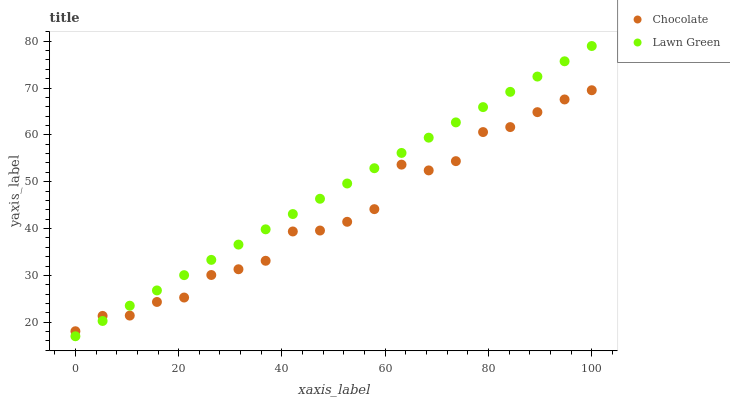Does Chocolate have the minimum area under the curve?
Answer yes or no. Yes. Does Lawn Green have the maximum area under the curve?
Answer yes or no. Yes. Does Chocolate have the maximum area under the curve?
Answer yes or no. No. Is Lawn Green the smoothest?
Answer yes or no. Yes. Is Chocolate the roughest?
Answer yes or no. Yes. Is Chocolate the smoothest?
Answer yes or no. No. Does Lawn Green have the lowest value?
Answer yes or no. Yes. Does Chocolate have the lowest value?
Answer yes or no. No. Does Lawn Green have the highest value?
Answer yes or no. Yes. Does Chocolate have the highest value?
Answer yes or no. No. Does Lawn Green intersect Chocolate?
Answer yes or no. Yes. Is Lawn Green less than Chocolate?
Answer yes or no. No. Is Lawn Green greater than Chocolate?
Answer yes or no. No. 